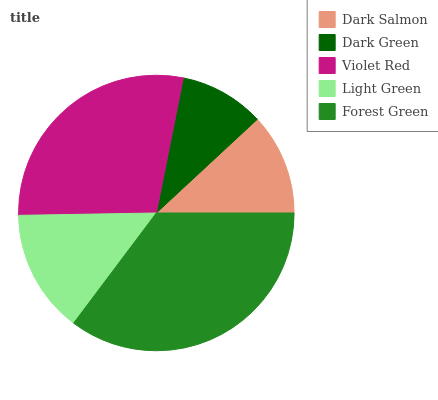Is Dark Green the minimum?
Answer yes or no. Yes. Is Forest Green the maximum?
Answer yes or no. Yes. Is Violet Red the minimum?
Answer yes or no. No. Is Violet Red the maximum?
Answer yes or no. No. Is Violet Red greater than Dark Green?
Answer yes or no. Yes. Is Dark Green less than Violet Red?
Answer yes or no. Yes. Is Dark Green greater than Violet Red?
Answer yes or no. No. Is Violet Red less than Dark Green?
Answer yes or no. No. Is Light Green the high median?
Answer yes or no. Yes. Is Light Green the low median?
Answer yes or no. Yes. Is Dark Salmon the high median?
Answer yes or no. No. Is Forest Green the low median?
Answer yes or no. No. 